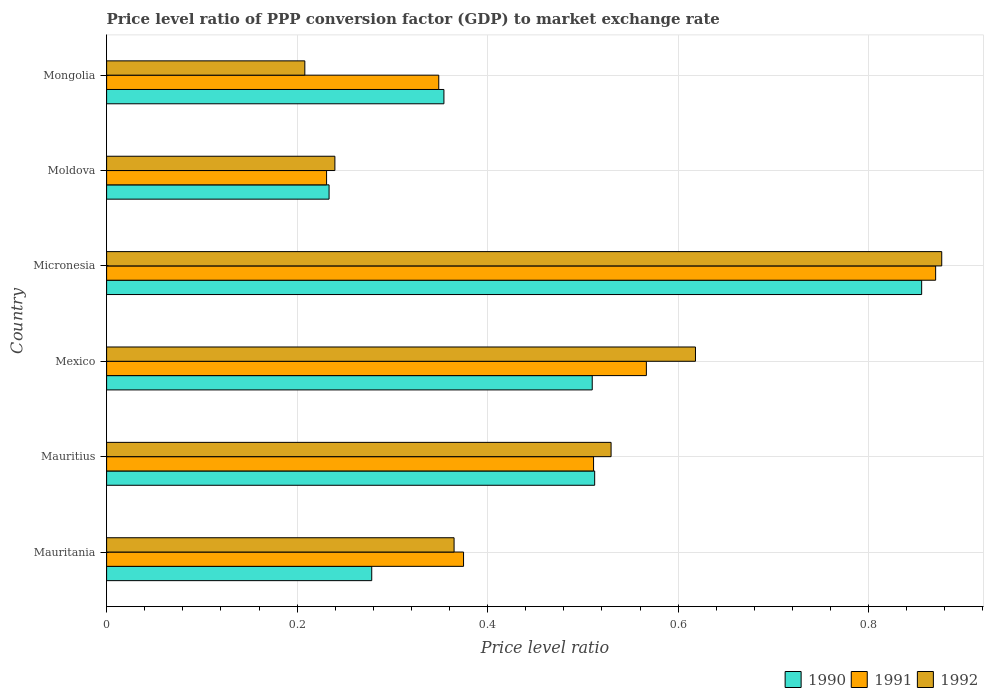How many groups of bars are there?
Provide a succinct answer. 6. Are the number of bars on each tick of the Y-axis equal?
Offer a very short reply. Yes. How many bars are there on the 1st tick from the top?
Make the answer very short. 3. How many bars are there on the 5th tick from the bottom?
Your response must be concise. 3. What is the label of the 5th group of bars from the top?
Offer a terse response. Mauritius. In how many cases, is the number of bars for a given country not equal to the number of legend labels?
Give a very brief answer. 0. What is the price level ratio in 1992 in Mauritius?
Give a very brief answer. 0.53. Across all countries, what is the maximum price level ratio in 1991?
Offer a terse response. 0.87. Across all countries, what is the minimum price level ratio in 1990?
Your response must be concise. 0.23. In which country was the price level ratio in 1992 maximum?
Offer a terse response. Micronesia. In which country was the price level ratio in 1992 minimum?
Make the answer very short. Mongolia. What is the total price level ratio in 1990 in the graph?
Keep it short and to the point. 2.74. What is the difference between the price level ratio in 1990 in Mauritania and that in Mexico?
Provide a succinct answer. -0.23. What is the difference between the price level ratio in 1990 in Moldova and the price level ratio in 1991 in Micronesia?
Your response must be concise. -0.64. What is the average price level ratio in 1991 per country?
Your answer should be very brief. 0.48. What is the difference between the price level ratio in 1991 and price level ratio in 1990 in Moldova?
Your response must be concise. -0. What is the ratio of the price level ratio in 1991 in Mexico to that in Micronesia?
Your answer should be very brief. 0.65. Is the price level ratio in 1990 in Moldova less than that in Mongolia?
Your response must be concise. Yes. What is the difference between the highest and the second highest price level ratio in 1992?
Your response must be concise. 0.26. What is the difference between the highest and the lowest price level ratio in 1991?
Your response must be concise. 0.64. What does the 1st bar from the top in Mauritius represents?
Keep it short and to the point. 1992. Is it the case that in every country, the sum of the price level ratio in 1992 and price level ratio in 1990 is greater than the price level ratio in 1991?
Ensure brevity in your answer.  Yes. How many bars are there?
Your response must be concise. 18. How many countries are there in the graph?
Offer a terse response. 6. What is the difference between two consecutive major ticks on the X-axis?
Offer a very short reply. 0.2. Where does the legend appear in the graph?
Give a very brief answer. Bottom right. What is the title of the graph?
Offer a very short reply. Price level ratio of PPP conversion factor (GDP) to market exchange rate. Does "1963" appear as one of the legend labels in the graph?
Your answer should be very brief. No. What is the label or title of the X-axis?
Provide a short and direct response. Price level ratio. What is the label or title of the Y-axis?
Provide a short and direct response. Country. What is the Price level ratio of 1990 in Mauritania?
Ensure brevity in your answer.  0.28. What is the Price level ratio of 1991 in Mauritania?
Offer a terse response. 0.37. What is the Price level ratio in 1992 in Mauritania?
Your answer should be compact. 0.36. What is the Price level ratio of 1990 in Mauritius?
Give a very brief answer. 0.51. What is the Price level ratio in 1991 in Mauritius?
Offer a very short reply. 0.51. What is the Price level ratio of 1992 in Mauritius?
Make the answer very short. 0.53. What is the Price level ratio of 1990 in Mexico?
Keep it short and to the point. 0.51. What is the Price level ratio in 1991 in Mexico?
Provide a short and direct response. 0.57. What is the Price level ratio of 1992 in Mexico?
Give a very brief answer. 0.62. What is the Price level ratio in 1990 in Micronesia?
Offer a very short reply. 0.86. What is the Price level ratio in 1991 in Micronesia?
Ensure brevity in your answer.  0.87. What is the Price level ratio in 1992 in Micronesia?
Ensure brevity in your answer.  0.88. What is the Price level ratio in 1990 in Moldova?
Offer a very short reply. 0.23. What is the Price level ratio in 1991 in Moldova?
Ensure brevity in your answer.  0.23. What is the Price level ratio in 1992 in Moldova?
Make the answer very short. 0.24. What is the Price level ratio in 1990 in Mongolia?
Offer a very short reply. 0.35. What is the Price level ratio in 1991 in Mongolia?
Offer a terse response. 0.35. What is the Price level ratio of 1992 in Mongolia?
Provide a short and direct response. 0.21. Across all countries, what is the maximum Price level ratio in 1990?
Offer a very short reply. 0.86. Across all countries, what is the maximum Price level ratio of 1991?
Your response must be concise. 0.87. Across all countries, what is the maximum Price level ratio in 1992?
Give a very brief answer. 0.88. Across all countries, what is the minimum Price level ratio of 1990?
Offer a terse response. 0.23. Across all countries, what is the minimum Price level ratio in 1991?
Give a very brief answer. 0.23. Across all countries, what is the minimum Price level ratio in 1992?
Your answer should be compact. 0.21. What is the total Price level ratio of 1990 in the graph?
Offer a terse response. 2.74. What is the total Price level ratio in 1991 in the graph?
Ensure brevity in your answer.  2.9. What is the total Price level ratio of 1992 in the graph?
Offer a very short reply. 2.84. What is the difference between the Price level ratio in 1990 in Mauritania and that in Mauritius?
Provide a succinct answer. -0.23. What is the difference between the Price level ratio of 1991 in Mauritania and that in Mauritius?
Make the answer very short. -0.14. What is the difference between the Price level ratio of 1992 in Mauritania and that in Mauritius?
Provide a short and direct response. -0.16. What is the difference between the Price level ratio in 1990 in Mauritania and that in Mexico?
Give a very brief answer. -0.23. What is the difference between the Price level ratio of 1991 in Mauritania and that in Mexico?
Offer a terse response. -0.19. What is the difference between the Price level ratio in 1992 in Mauritania and that in Mexico?
Your answer should be compact. -0.25. What is the difference between the Price level ratio of 1990 in Mauritania and that in Micronesia?
Give a very brief answer. -0.58. What is the difference between the Price level ratio of 1991 in Mauritania and that in Micronesia?
Offer a terse response. -0.5. What is the difference between the Price level ratio of 1992 in Mauritania and that in Micronesia?
Make the answer very short. -0.51. What is the difference between the Price level ratio of 1990 in Mauritania and that in Moldova?
Your response must be concise. 0.04. What is the difference between the Price level ratio in 1991 in Mauritania and that in Moldova?
Offer a terse response. 0.14. What is the difference between the Price level ratio in 1992 in Mauritania and that in Moldova?
Your response must be concise. 0.13. What is the difference between the Price level ratio of 1990 in Mauritania and that in Mongolia?
Your response must be concise. -0.08. What is the difference between the Price level ratio in 1991 in Mauritania and that in Mongolia?
Keep it short and to the point. 0.03. What is the difference between the Price level ratio of 1992 in Mauritania and that in Mongolia?
Your answer should be very brief. 0.16. What is the difference between the Price level ratio in 1990 in Mauritius and that in Mexico?
Provide a succinct answer. 0. What is the difference between the Price level ratio of 1991 in Mauritius and that in Mexico?
Offer a very short reply. -0.06. What is the difference between the Price level ratio in 1992 in Mauritius and that in Mexico?
Make the answer very short. -0.09. What is the difference between the Price level ratio of 1990 in Mauritius and that in Micronesia?
Provide a succinct answer. -0.34. What is the difference between the Price level ratio of 1991 in Mauritius and that in Micronesia?
Provide a succinct answer. -0.36. What is the difference between the Price level ratio of 1992 in Mauritius and that in Micronesia?
Give a very brief answer. -0.35. What is the difference between the Price level ratio of 1990 in Mauritius and that in Moldova?
Your answer should be very brief. 0.28. What is the difference between the Price level ratio of 1991 in Mauritius and that in Moldova?
Your answer should be very brief. 0.28. What is the difference between the Price level ratio of 1992 in Mauritius and that in Moldova?
Your answer should be compact. 0.29. What is the difference between the Price level ratio in 1990 in Mauritius and that in Mongolia?
Offer a terse response. 0.16. What is the difference between the Price level ratio in 1991 in Mauritius and that in Mongolia?
Offer a very short reply. 0.16. What is the difference between the Price level ratio in 1992 in Mauritius and that in Mongolia?
Provide a succinct answer. 0.32. What is the difference between the Price level ratio in 1990 in Mexico and that in Micronesia?
Your answer should be compact. -0.35. What is the difference between the Price level ratio in 1991 in Mexico and that in Micronesia?
Provide a short and direct response. -0.3. What is the difference between the Price level ratio of 1992 in Mexico and that in Micronesia?
Offer a terse response. -0.26. What is the difference between the Price level ratio of 1990 in Mexico and that in Moldova?
Your answer should be compact. 0.28. What is the difference between the Price level ratio of 1991 in Mexico and that in Moldova?
Give a very brief answer. 0.34. What is the difference between the Price level ratio in 1992 in Mexico and that in Moldova?
Make the answer very short. 0.38. What is the difference between the Price level ratio of 1990 in Mexico and that in Mongolia?
Offer a very short reply. 0.16. What is the difference between the Price level ratio in 1991 in Mexico and that in Mongolia?
Provide a short and direct response. 0.22. What is the difference between the Price level ratio in 1992 in Mexico and that in Mongolia?
Your response must be concise. 0.41. What is the difference between the Price level ratio in 1990 in Micronesia and that in Moldova?
Keep it short and to the point. 0.62. What is the difference between the Price level ratio in 1991 in Micronesia and that in Moldova?
Offer a very short reply. 0.64. What is the difference between the Price level ratio in 1992 in Micronesia and that in Moldova?
Your answer should be very brief. 0.64. What is the difference between the Price level ratio in 1990 in Micronesia and that in Mongolia?
Provide a short and direct response. 0.5. What is the difference between the Price level ratio in 1991 in Micronesia and that in Mongolia?
Give a very brief answer. 0.52. What is the difference between the Price level ratio in 1992 in Micronesia and that in Mongolia?
Provide a short and direct response. 0.67. What is the difference between the Price level ratio of 1990 in Moldova and that in Mongolia?
Make the answer very short. -0.12. What is the difference between the Price level ratio of 1991 in Moldova and that in Mongolia?
Make the answer very short. -0.12. What is the difference between the Price level ratio of 1992 in Moldova and that in Mongolia?
Your answer should be very brief. 0.03. What is the difference between the Price level ratio in 1990 in Mauritania and the Price level ratio in 1991 in Mauritius?
Keep it short and to the point. -0.23. What is the difference between the Price level ratio of 1990 in Mauritania and the Price level ratio of 1992 in Mauritius?
Make the answer very short. -0.25. What is the difference between the Price level ratio in 1991 in Mauritania and the Price level ratio in 1992 in Mauritius?
Your answer should be compact. -0.15. What is the difference between the Price level ratio of 1990 in Mauritania and the Price level ratio of 1991 in Mexico?
Make the answer very short. -0.29. What is the difference between the Price level ratio in 1990 in Mauritania and the Price level ratio in 1992 in Mexico?
Your response must be concise. -0.34. What is the difference between the Price level ratio in 1991 in Mauritania and the Price level ratio in 1992 in Mexico?
Make the answer very short. -0.24. What is the difference between the Price level ratio of 1990 in Mauritania and the Price level ratio of 1991 in Micronesia?
Give a very brief answer. -0.59. What is the difference between the Price level ratio in 1990 in Mauritania and the Price level ratio in 1992 in Micronesia?
Give a very brief answer. -0.6. What is the difference between the Price level ratio in 1991 in Mauritania and the Price level ratio in 1992 in Micronesia?
Your answer should be very brief. -0.5. What is the difference between the Price level ratio in 1990 in Mauritania and the Price level ratio in 1991 in Moldova?
Keep it short and to the point. 0.05. What is the difference between the Price level ratio of 1990 in Mauritania and the Price level ratio of 1992 in Moldova?
Keep it short and to the point. 0.04. What is the difference between the Price level ratio in 1991 in Mauritania and the Price level ratio in 1992 in Moldova?
Your response must be concise. 0.14. What is the difference between the Price level ratio of 1990 in Mauritania and the Price level ratio of 1991 in Mongolia?
Ensure brevity in your answer.  -0.07. What is the difference between the Price level ratio in 1990 in Mauritania and the Price level ratio in 1992 in Mongolia?
Your answer should be compact. 0.07. What is the difference between the Price level ratio in 1991 in Mauritania and the Price level ratio in 1992 in Mongolia?
Keep it short and to the point. 0.17. What is the difference between the Price level ratio of 1990 in Mauritius and the Price level ratio of 1991 in Mexico?
Offer a terse response. -0.05. What is the difference between the Price level ratio of 1990 in Mauritius and the Price level ratio of 1992 in Mexico?
Ensure brevity in your answer.  -0.11. What is the difference between the Price level ratio in 1991 in Mauritius and the Price level ratio in 1992 in Mexico?
Your answer should be compact. -0.11. What is the difference between the Price level ratio in 1990 in Mauritius and the Price level ratio in 1991 in Micronesia?
Ensure brevity in your answer.  -0.36. What is the difference between the Price level ratio of 1990 in Mauritius and the Price level ratio of 1992 in Micronesia?
Your answer should be compact. -0.36. What is the difference between the Price level ratio in 1991 in Mauritius and the Price level ratio in 1992 in Micronesia?
Your answer should be very brief. -0.37. What is the difference between the Price level ratio in 1990 in Mauritius and the Price level ratio in 1991 in Moldova?
Provide a short and direct response. 0.28. What is the difference between the Price level ratio of 1990 in Mauritius and the Price level ratio of 1992 in Moldova?
Give a very brief answer. 0.27. What is the difference between the Price level ratio of 1991 in Mauritius and the Price level ratio of 1992 in Moldova?
Provide a succinct answer. 0.27. What is the difference between the Price level ratio of 1990 in Mauritius and the Price level ratio of 1991 in Mongolia?
Provide a succinct answer. 0.16. What is the difference between the Price level ratio of 1990 in Mauritius and the Price level ratio of 1992 in Mongolia?
Offer a very short reply. 0.3. What is the difference between the Price level ratio in 1991 in Mauritius and the Price level ratio in 1992 in Mongolia?
Offer a terse response. 0.3. What is the difference between the Price level ratio of 1990 in Mexico and the Price level ratio of 1991 in Micronesia?
Offer a very short reply. -0.36. What is the difference between the Price level ratio in 1990 in Mexico and the Price level ratio in 1992 in Micronesia?
Make the answer very short. -0.37. What is the difference between the Price level ratio of 1991 in Mexico and the Price level ratio of 1992 in Micronesia?
Make the answer very short. -0.31. What is the difference between the Price level ratio in 1990 in Mexico and the Price level ratio in 1991 in Moldova?
Provide a short and direct response. 0.28. What is the difference between the Price level ratio of 1990 in Mexico and the Price level ratio of 1992 in Moldova?
Your response must be concise. 0.27. What is the difference between the Price level ratio of 1991 in Mexico and the Price level ratio of 1992 in Moldova?
Offer a terse response. 0.33. What is the difference between the Price level ratio in 1990 in Mexico and the Price level ratio in 1991 in Mongolia?
Your response must be concise. 0.16. What is the difference between the Price level ratio in 1990 in Mexico and the Price level ratio in 1992 in Mongolia?
Your answer should be very brief. 0.3. What is the difference between the Price level ratio in 1991 in Mexico and the Price level ratio in 1992 in Mongolia?
Offer a very short reply. 0.36. What is the difference between the Price level ratio in 1990 in Micronesia and the Price level ratio in 1991 in Moldova?
Keep it short and to the point. 0.62. What is the difference between the Price level ratio of 1990 in Micronesia and the Price level ratio of 1992 in Moldova?
Offer a terse response. 0.62. What is the difference between the Price level ratio of 1991 in Micronesia and the Price level ratio of 1992 in Moldova?
Provide a succinct answer. 0.63. What is the difference between the Price level ratio in 1990 in Micronesia and the Price level ratio in 1991 in Mongolia?
Make the answer very short. 0.51. What is the difference between the Price level ratio in 1990 in Micronesia and the Price level ratio in 1992 in Mongolia?
Give a very brief answer. 0.65. What is the difference between the Price level ratio in 1991 in Micronesia and the Price level ratio in 1992 in Mongolia?
Offer a very short reply. 0.66. What is the difference between the Price level ratio in 1990 in Moldova and the Price level ratio in 1991 in Mongolia?
Your answer should be very brief. -0.12. What is the difference between the Price level ratio in 1990 in Moldova and the Price level ratio in 1992 in Mongolia?
Your response must be concise. 0.03. What is the difference between the Price level ratio of 1991 in Moldova and the Price level ratio of 1992 in Mongolia?
Keep it short and to the point. 0.02. What is the average Price level ratio of 1990 per country?
Give a very brief answer. 0.46. What is the average Price level ratio in 1991 per country?
Give a very brief answer. 0.48. What is the average Price level ratio of 1992 per country?
Provide a short and direct response. 0.47. What is the difference between the Price level ratio in 1990 and Price level ratio in 1991 in Mauritania?
Offer a very short reply. -0.1. What is the difference between the Price level ratio of 1990 and Price level ratio of 1992 in Mauritania?
Make the answer very short. -0.09. What is the difference between the Price level ratio in 1991 and Price level ratio in 1992 in Mauritania?
Your response must be concise. 0.01. What is the difference between the Price level ratio in 1990 and Price level ratio in 1991 in Mauritius?
Ensure brevity in your answer.  0. What is the difference between the Price level ratio in 1990 and Price level ratio in 1992 in Mauritius?
Your answer should be very brief. -0.02. What is the difference between the Price level ratio in 1991 and Price level ratio in 1992 in Mauritius?
Your answer should be very brief. -0.02. What is the difference between the Price level ratio of 1990 and Price level ratio of 1991 in Mexico?
Your response must be concise. -0.06. What is the difference between the Price level ratio of 1990 and Price level ratio of 1992 in Mexico?
Provide a short and direct response. -0.11. What is the difference between the Price level ratio of 1991 and Price level ratio of 1992 in Mexico?
Provide a short and direct response. -0.05. What is the difference between the Price level ratio in 1990 and Price level ratio in 1991 in Micronesia?
Keep it short and to the point. -0.01. What is the difference between the Price level ratio in 1990 and Price level ratio in 1992 in Micronesia?
Keep it short and to the point. -0.02. What is the difference between the Price level ratio of 1991 and Price level ratio of 1992 in Micronesia?
Give a very brief answer. -0.01. What is the difference between the Price level ratio in 1990 and Price level ratio in 1991 in Moldova?
Offer a terse response. 0. What is the difference between the Price level ratio of 1990 and Price level ratio of 1992 in Moldova?
Your answer should be compact. -0.01. What is the difference between the Price level ratio in 1991 and Price level ratio in 1992 in Moldova?
Offer a very short reply. -0.01. What is the difference between the Price level ratio in 1990 and Price level ratio in 1991 in Mongolia?
Keep it short and to the point. 0.01. What is the difference between the Price level ratio of 1990 and Price level ratio of 1992 in Mongolia?
Your response must be concise. 0.15. What is the difference between the Price level ratio in 1991 and Price level ratio in 1992 in Mongolia?
Make the answer very short. 0.14. What is the ratio of the Price level ratio of 1990 in Mauritania to that in Mauritius?
Your response must be concise. 0.54. What is the ratio of the Price level ratio in 1991 in Mauritania to that in Mauritius?
Offer a very short reply. 0.73. What is the ratio of the Price level ratio of 1992 in Mauritania to that in Mauritius?
Your response must be concise. 0.69. What is the ratio of the Price level ratio in 1990 in Mauritania to that in Mexico?
Offer a terse response. 0.55. What is the ratio of the Price level ratio of 1991 in Mauritania to that in Mexico?
Ensure brevity in your answer.  0.66. What is the ratio of the Price level ratio of 1992 in Mauritania to that in Mexico?
Offer a very short reply. 0.59. What is the ratio of the Price level ratio in 1990 in Mauritania to that in Micronesia?
Ensure brevity in your answer.  0.33. What is the ratio of the Price level ratio of 1991 in Mauritania to that in Micronesia?
Make the answer very short. 0.43. What is the ratio of the Price level ratio in 1992 in Mauritania to that in Micronesia?
Make the answer very short. 0.42. What is the ratio of the Price level ratio in 1990 in Mauritania to that in Moldova?
Offer a very short reply. 1.19. What is the ratio of the Price level ratio in 1991 in Mauritania to that in Moldova?
Your answer should be very brief. 1.62. What is the ratio of the Price level ratio in 1992 in Mauritania to that in Moldova?
Offer a terse response. 1.52. What is the ratio of the Price level ratio of 1990 in Mauritania to that in Mongolia?
Give a very brief answer. 0.79. What is the ratio of the Price level ratio of 1991 in Mauritania to that in Mongolia?
Offer a terse response. 1.07. What is the ratio of the Price level ratio in 1992 in Mauritania to that in Mongolia?
Keep it short and to the point. 1.75. What is the ratio of the Price level ratio of 1990 in Mauritius to that in Mexico?
Your answer should be very brief. 1. What is the ratio of the Price level ratio in 1991 in Mauritius to that in Mexico?
Your answer should be very brief. 0.9. What is the ratio of the Price level ratio in 1992 in Mauritius to that in Mexico?
Make the answer very short. 0.86. What is the ratio of the Price level ratio in 1990 in Mauritius to that in Micronesia?
Give a very brief answer. 0.6. What is the ratio of the Price level ratio of 1991 in Mauritius to that in Micronesia?
Give a very brief answer. 0.59. What is the ratio of the Price level ratio of 1992 in Mauritius to that in Micronesia?
Provide a short and direct response. 0.6. What is the ratio of the Price level ratio of 1990 in Mauritius to that in Moldova?
Keep it short and to the point. 2.19. What is the ratio of the Price level ratio of 1991 in Mauritius to that in Moldova?
Ensure brevity in your answer.  2.21. What is the ratio of the Price level ratio in 1992 in Mauritius to that in Moldova?
Give a very brief answer. 2.21. What is the ratio of the Price level ratio of 1990 in Mauritius to that in Mongolia?
Ensure brevity in your answer.  1.45. What is the ratio of the Price level ratio of 1991 in Mauritius to that in Mongolia?
Offer a terse response. 1.47. What is the ratio of the Price level ratio of 1992 in Mauritius to that in Mongolia?
Offer a very short reply. 2.55. What is the ratio of the Price level ratio in 1990 in Mexico to that in Micronesia?
Make the answer very short. 0.6. What is the ratio of the Price level ratio of 1991 in Mexico to that in Micronesia?
Offer a terse response. 0.65. What is the ratio of the Price level ratio of 1992 in Mexico to that in Micronesia?
Ensure brevity in your answer.  0.71. What is the ratio of the Price level ratio in 1990 in Mexico to that in Moldova?
Your answer should be very brief. 2.18. What is the ratio of the Price level ratio of 1991 in Mexico to that in Moldova?
Make the answer very short. 2.45. What is the ratio of the Price level ratio in 1992 in Mexico to that in Moldova?
Offer a very short reply. 2.58. What is the ratio of the Price level ratio of 1990 in Mexico to that in Mongolia?
Keep it short and to the point. 1.44. What is the ratio of the Price level ratio of 1991 in Mexico to that in Mongolia?
Ensure brevity in your answer.  1.62. What is the ratio of the Price level ratio in 1992 in Mexico to that in Mongolia?
Offer a terse response. 2.97. What is the ratio of the Price level ratio in 1990 in Micronesia to that in Moldova?
Offer a terse response. 3.66. What is the ratio of the Price level ratio of 1991 in Micronesia to that in Moldova?
Give a very brief answer. 3.77. What is the ratio of the Price level ratio of 1992 in Micronesia to that in Moldova?
Your response must be concise. 3.66. What is the ratio of the Price level ratio in 1990 in Micronesia to that in Mongolia?
Provide a succinct answer. 2.42. What is the ratio of the Price level ratio of 1991 in Micronesia to that in Mongolia?
Ensure brevity in your answer.  2.5. What is the ratio of the Price level ratio in 1992 in Micronesia to that in Mongolia?
Give a very brief answer. 4.21. What is the ratio of the Price level ratio of 1990 in Moldova to that in Mongolia?
Make the answer very short. 0.66. What is the ratio of the Price level ratio in 1991 in Moldova to that in Mongolia?
Give a very brief answer. 0.66. What is the ratio of the Price level ratio of 1992 in Moldova to that in Mongolia?
Make the answer very short. 1.15. What is the difference between the highest and the second highest Price level ratio in 1990?
Offer a very short reply. 0.34. What is the difference between the highest and the second highest Price level ratio in 1991?
Keep it short and to the point. 0.3. What is the difference between the highest and the second highest Price level ratio in 1992?
Give a very brief answer. 0.26. What is the difference between the highest and the lowest Price level ratio in 1990?
Ensure brevity in your answer.  0.62. What is the difference between the highest and the lowest Price level ratio in 1991?
Give a very brief answer. 0.64. What is the difference between the highest and the lowest Price level ratio in 1992?
Your answer should be very brief. 0.67. 